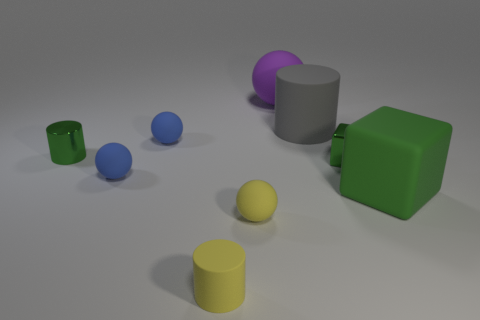There is a metal thing to the left of the green shiny object that is right of the matte cylinder that is in front of the tiny shiny cylinder; how big is it? The metal object appears to be relatively small in size, roughly similar to the small green shiny object nearby. It's positioned to the left of the green cube, which is to the right of the matte grey cylinder in front of the tiny shiny yellow cylinder. 